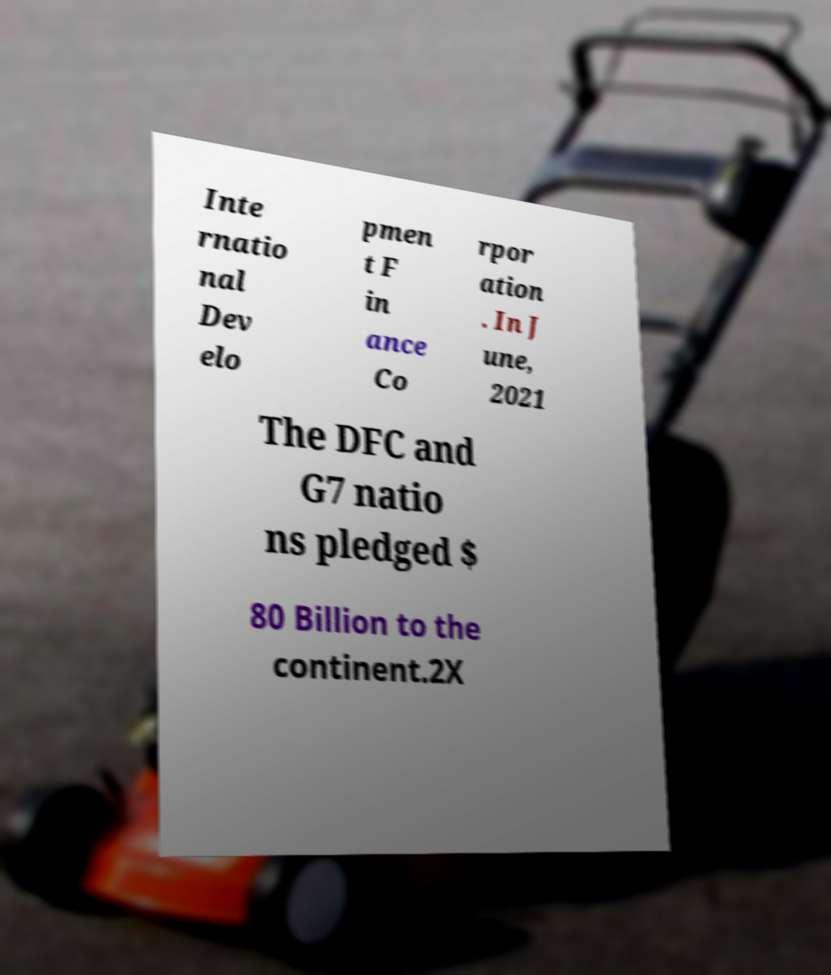Please identify and transcribe the text found in this image. Inte rnatio nal Dev elo pmen t F in ance Co rpor ation . In J une, 2021 The DFC and G7 natio ns pledged $ 80 Billion to the continent.2X 